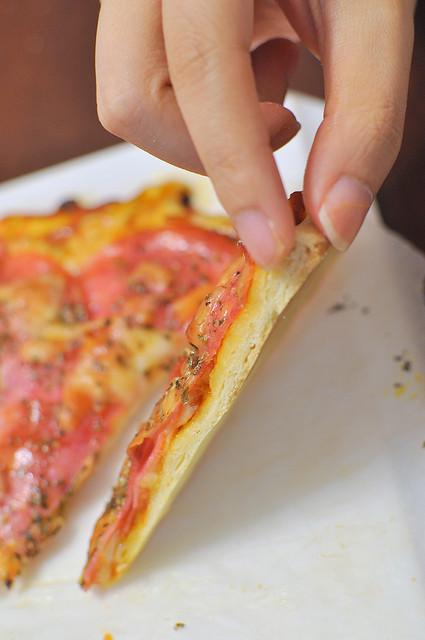Is this a Domino's pizza?
Short answer required. No. Is this an all cheese pizza?
Write a very short answer. No. Are there slices of pizza on the plate?
Be succinct. Yes. 